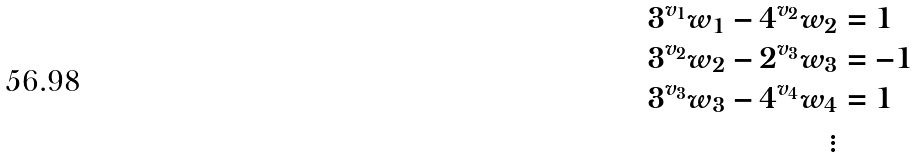Convert formula to latex. <formula><loc_0><loc_0><loc_500><loc_500>3 ^ { v _ { 1 } } w _ { 1 } - 4 ^ { v _ { 2 } } w _ { 2 } & = 1 \\ 3 ^ { v _ { 2 } } w _ { 2 } - 2 ^ { v _ { 3 } } w _ { 3 } & = - 1 \\ 3 ^ { v _ { 3 } } w _ { 3 } - 4 ^ { v _ { 4 } } w _ { 4 } & = 1 \\ \vdots &</formula> 